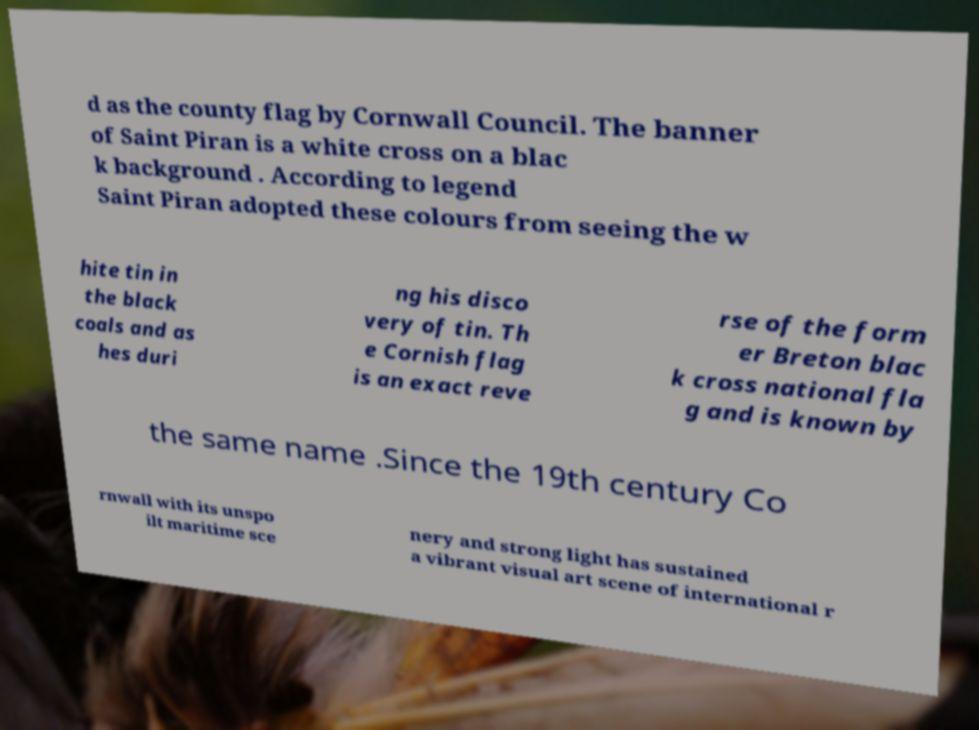Please identify and transcribe the text found in this image. d as the county flag by Cornwall Council. The banner of Saint Piran is a white cross on a blac k background . According to legend Saint Piran adopted these colours from seeing the w hite tin in the black coals and as hes duri ng his disco very of tin. Th e Cornish flag is an exact reve rse of the form er Breton blac k cross national fla g and is known by the same name .Since the 19th century Co rnwall with its unspo ilt maritime sce nery and strong light has sustained a vibrant visual art scene of international r 